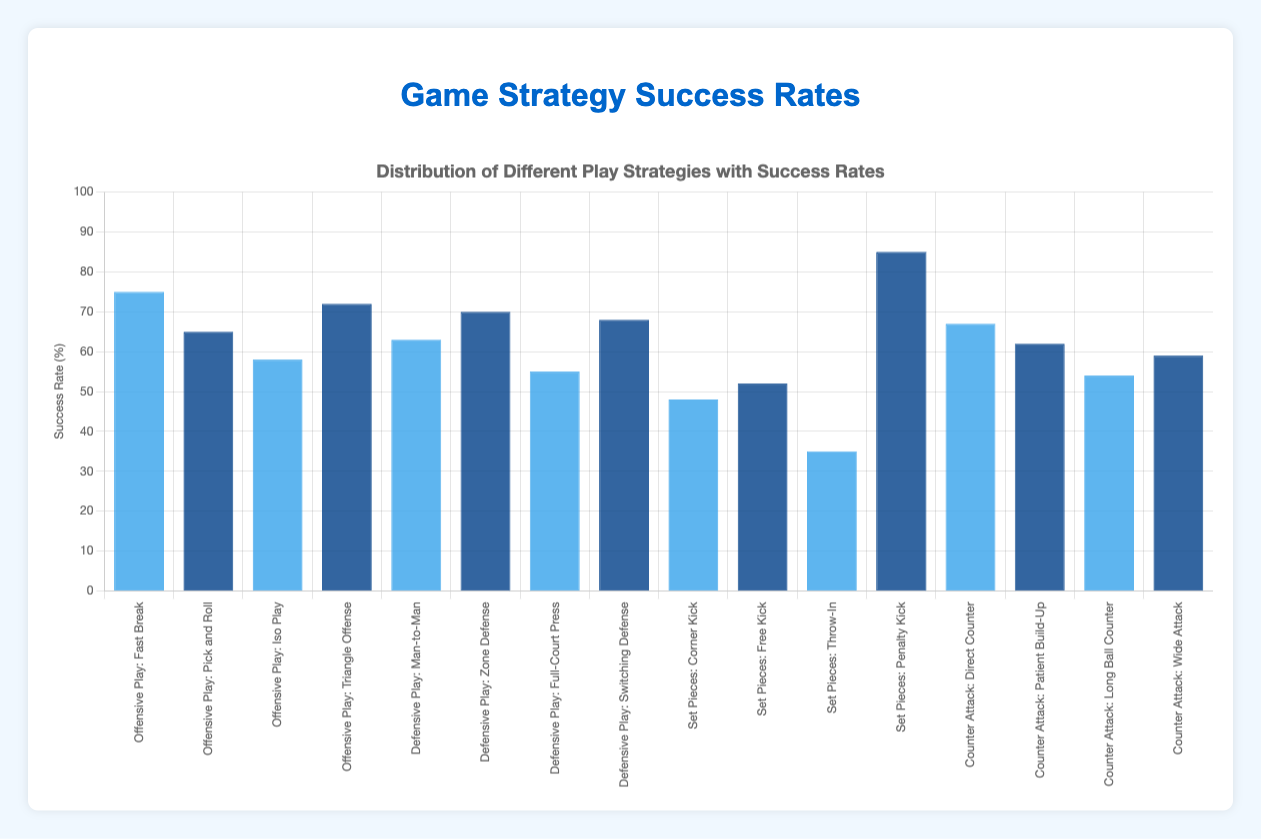What's the strategy with the highest success rate in Offensive Play? To find the strategy with the highest success rate in Offensive Play, look at the bars corresponding to Offensive Play strategies and compare their heights. The highest bar will reveal the strategy. The highest success rate is 75 for Fast Break.
Answer: Fast Break Which defensive strategy shows the lowest success rate? Among the defensive strategies (Man-to-Man, Zone Defense, Full-Court Press, Switching Defense), identify the shortest bar. The shortest bar corresponds to the Full-Court Press with a success rate of 55.
Answer: Full-Court Press What is the combined success rate of Iso Play and Wide Attack? Add the success rates of Iso Play (58) and Wide Attack (59). The combined rate is 58 + 59.
Answer: 117 Which scenario has the strategy with the lowest success rate overall? To find the scenario with the strategy with the lowest success rate, scan all strategies and find the smallest success rate. The lowest value is 35 for Throw-In under Set Pieces.
Answer: Set Pieces How much higher is the success rate for a Penalty Kick compared to a Throw-In? Calculate the difference in success rates between Penalty Kick (85) and Throw-In (35). The difference is 85 - 35.
Answer: 50 What is the average success rate of defensive strategies? Calculate the average by summing the success rates of the defensive strategies (63 + 70 + 55 + 68) and dividing by their number (4). The sum is 256, and the average is 256 / 4.
Answer: 64 Between Fast Break and Triangle Offense, which strategy has a higher success rate and by how much? Compare the success rates of Fast Break (75) and Triangle Offense (72). Fast Break is higher by 75 - 72.
Answer: Fast Break, 3 Which set piece strategy has the closest success rate to 50%? Among the set piece strategies (Corner Kick, Free Kick, Throw-In, Penalty Kick), find the success rate closest to 50. Free Kick has a success rate of 52, closest to 50.
Answer: Free Kick 